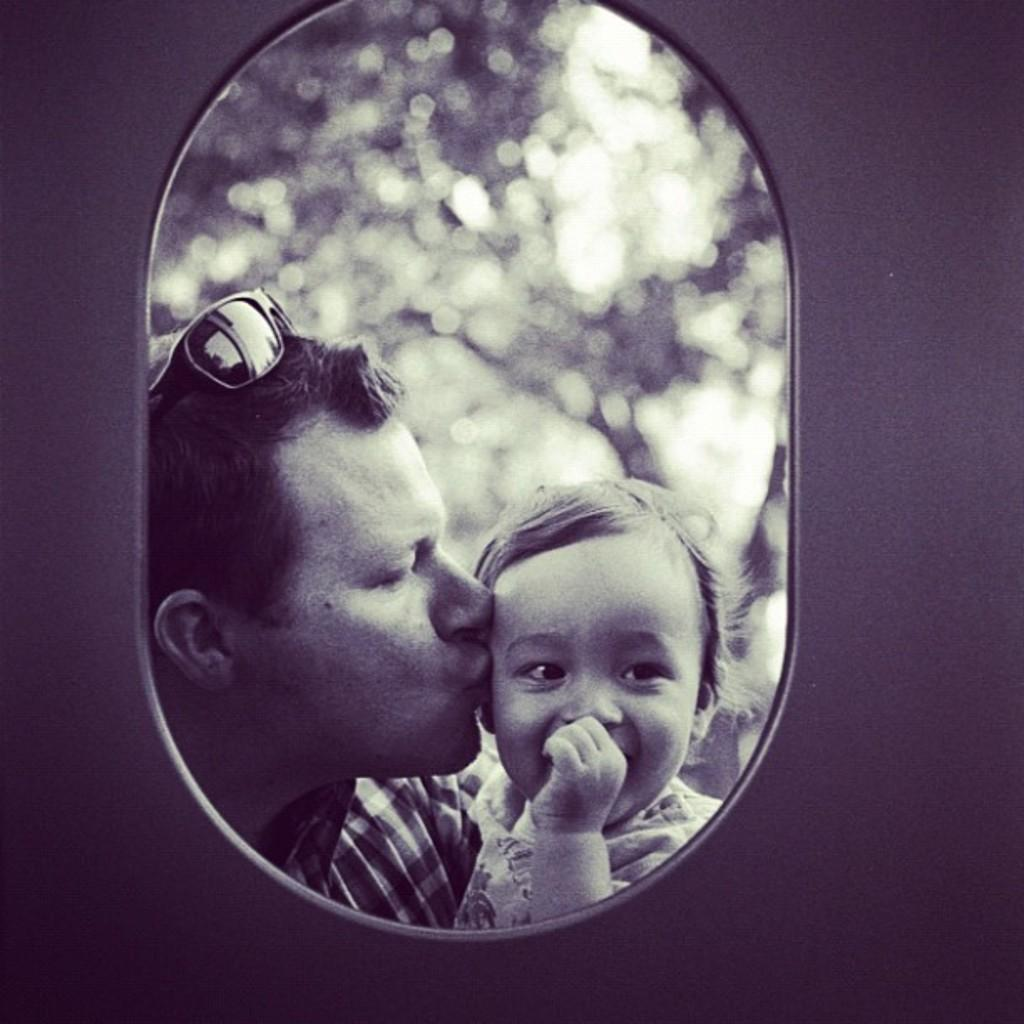Who is present in the image? There is a man and a child in the image. What are the man and the child wearing? Both the man and the child are wearing clothes. Can you describe any specific accessory the man is wearing? The man is wearing goggles. What can be seen in the background of the image? The background of the image is blurred. What type of planes can be seen flying in the background of the image? There are no planes visible in the image; the background is blurred. What is the governor doing in the image? There is no governor present in the image. 